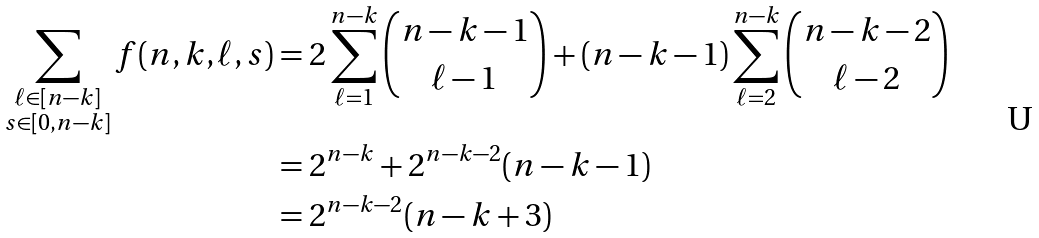Convert formula to latex. <formula><loc_0><loc_0><loc_500><loc_500>\sum _ { \substack { \ell \in [ n - k ] \\ s \in [ 0 , n - k ] } } f ( n , k , \ell , s ) & = 2 \sum _ { \ell = 1 } ^ { n - k } \binom { n - k - 1 } { \ell - 1 } + ( n - k - 1 ) \sum _ { \ell = 2 } ^ { n - k } \binom { n - k - 2 } { \ell - 2 } \\ & = 2 ^ { n - k } + 2 ^ { n - k - 2 } ( n - k - 1 ) \\ & = 2 ^ { n - k - 2 } ( n - k + 3 )</formula> 